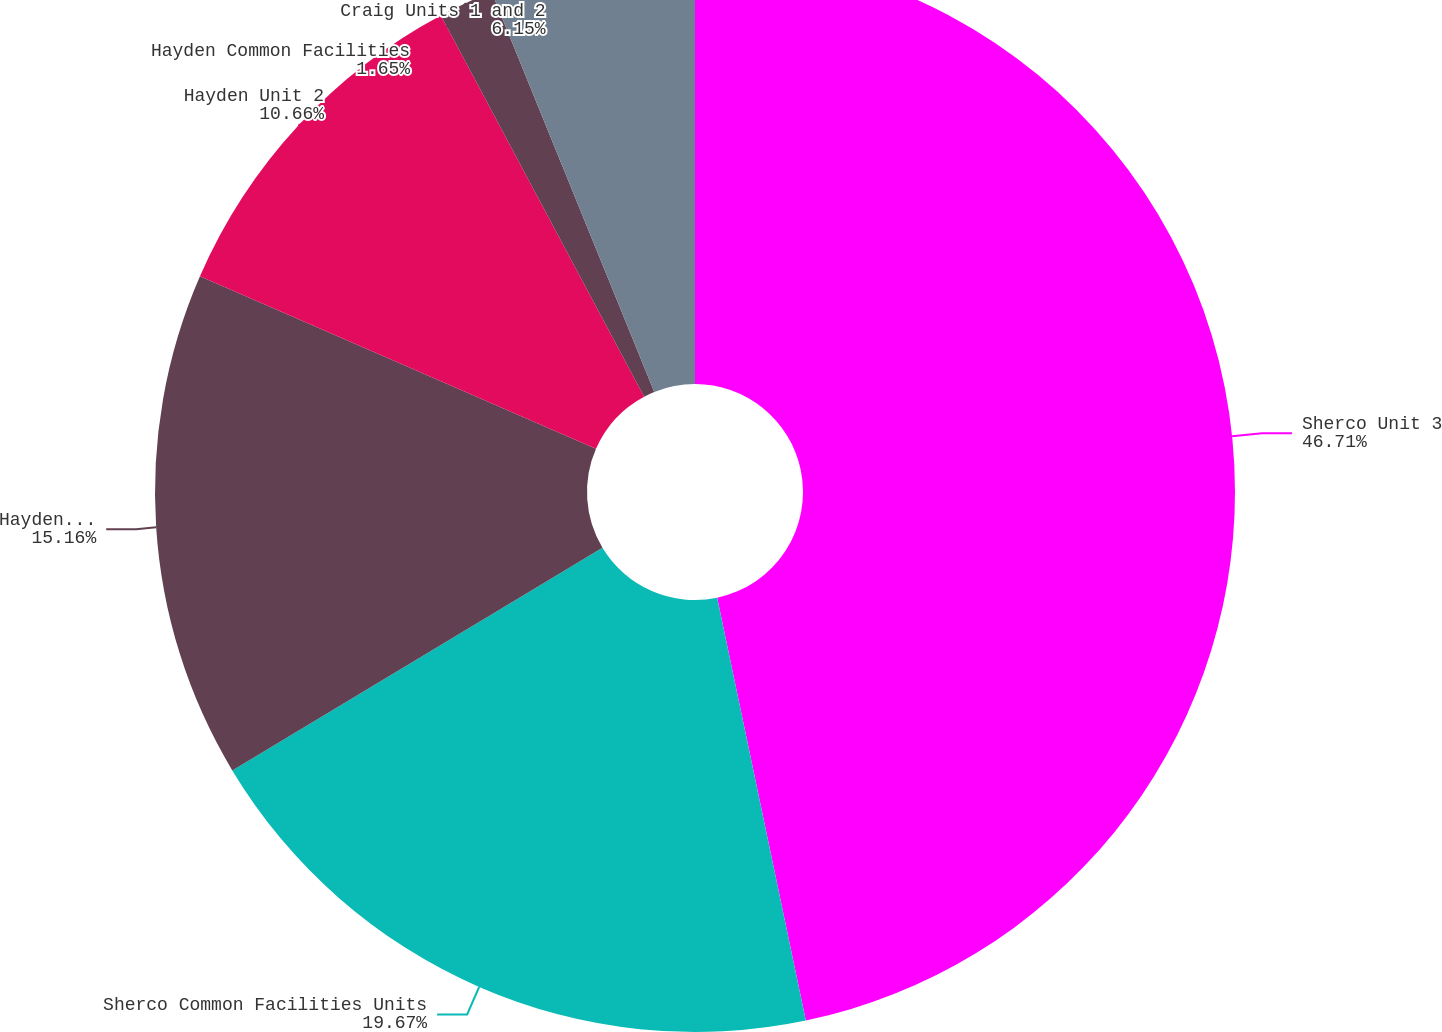<chart> <loc_0><loc_0><loc_500><loc_500><pie_chart><fcel>Sherco Unit 3<fcel>Sherco Common Facilities Units<fcel>Hayden Unit 1<fcel>Hayden Unit 2<fcel>Hayden Common Facilities<fcel>Craig Units 1 and 2<nl><fcel>46.71%<fcel>19.67%<fcel>15.16%<fcel>10.66%<fcel>1.65%<fcel>6.15%<nl></chart> 